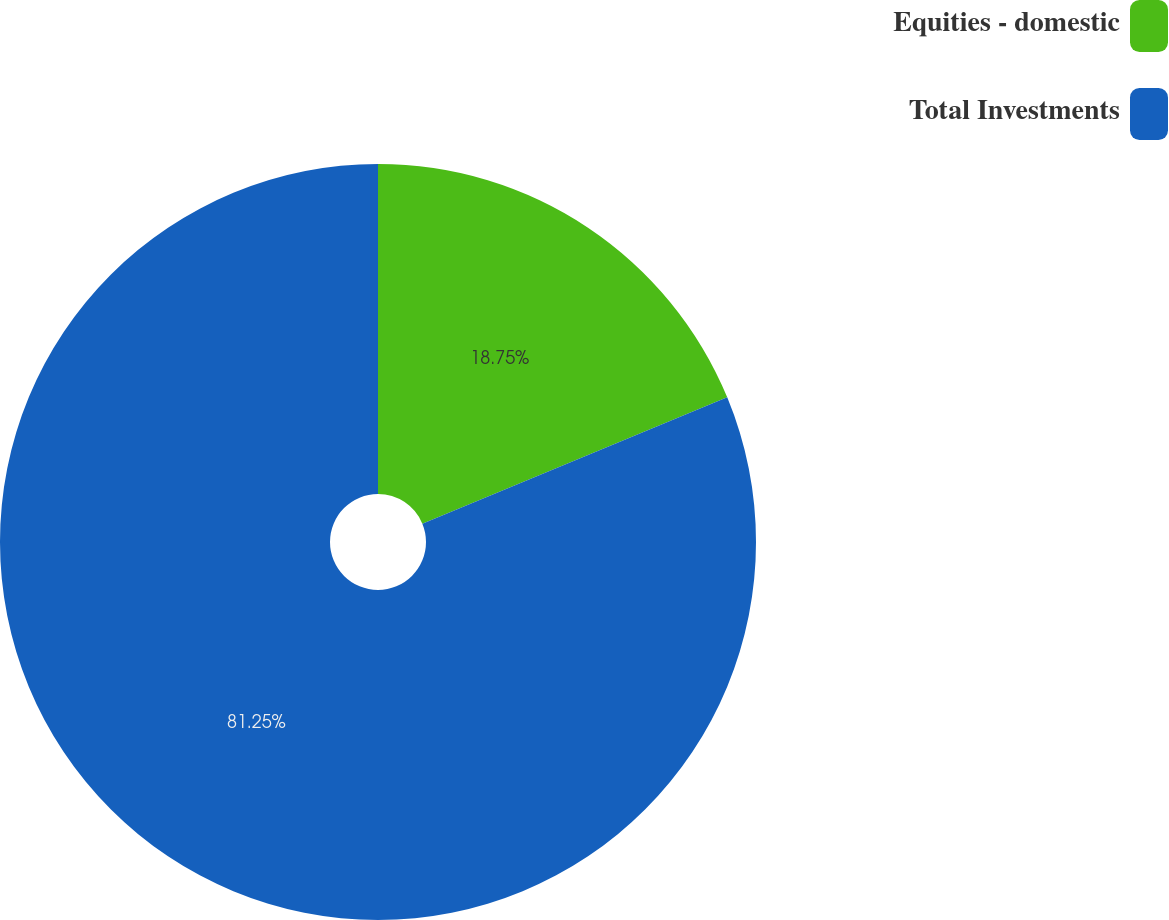Convert chart. <chart><loc_0><loc_0><loc_500><loc_500><pie_chart><fcel>Equities - domestic<fcel>Total Investments<nl><fcel>18.75%<fcel>81.25%<nl></chart> 